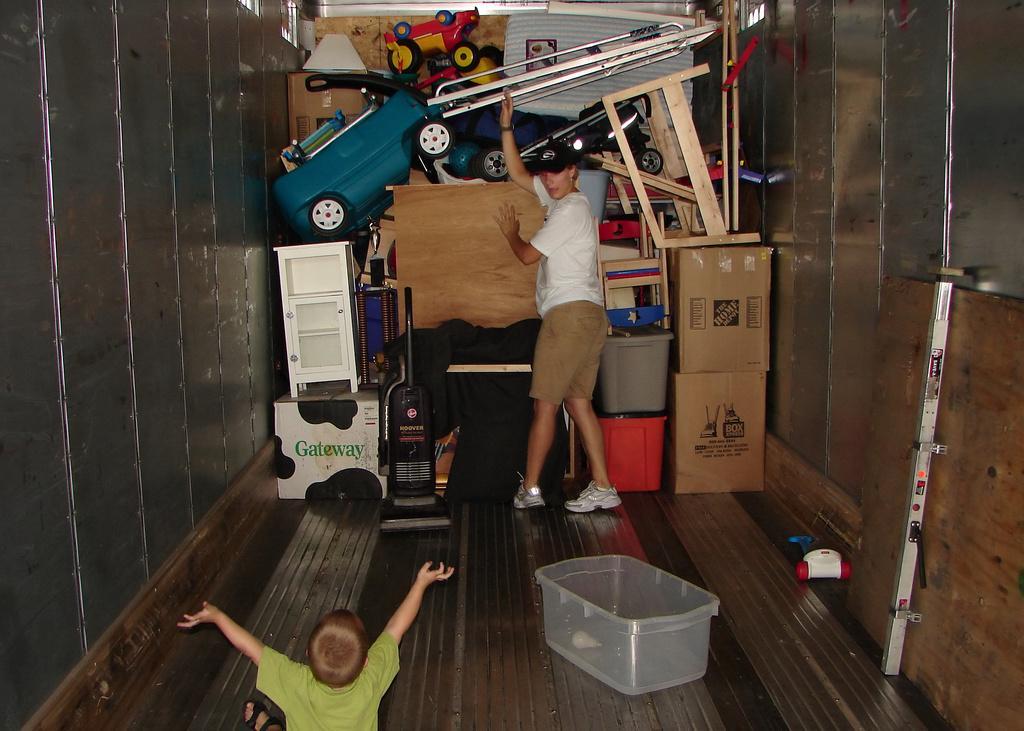How would you summarize this image in a sentence or two? In the image there is a kid sitting on floor,in the back there is a woman standing in the middle, in front of her there are many cupboards,toys,stands and frames and on either side there is wall. 